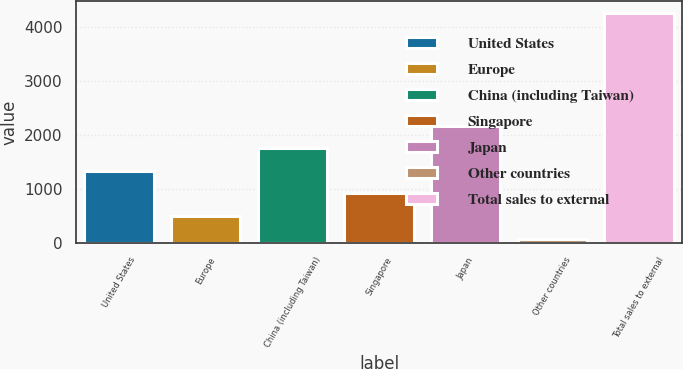Convert chart. <chart><loc_0><loc_0><loc_500><loc_500><bar_chart><fcel>United States<fcel>Europe<fcel>China (including Taiwan)<fcel>Singapore<fcel>Japan<fcel>Other countries<fcel>Total sales to external<nl><fcel>1332<fcel>492<fcel>1752<fcel>912<fcel>2172<fcel>72<fcel>4272<nl></chart> 